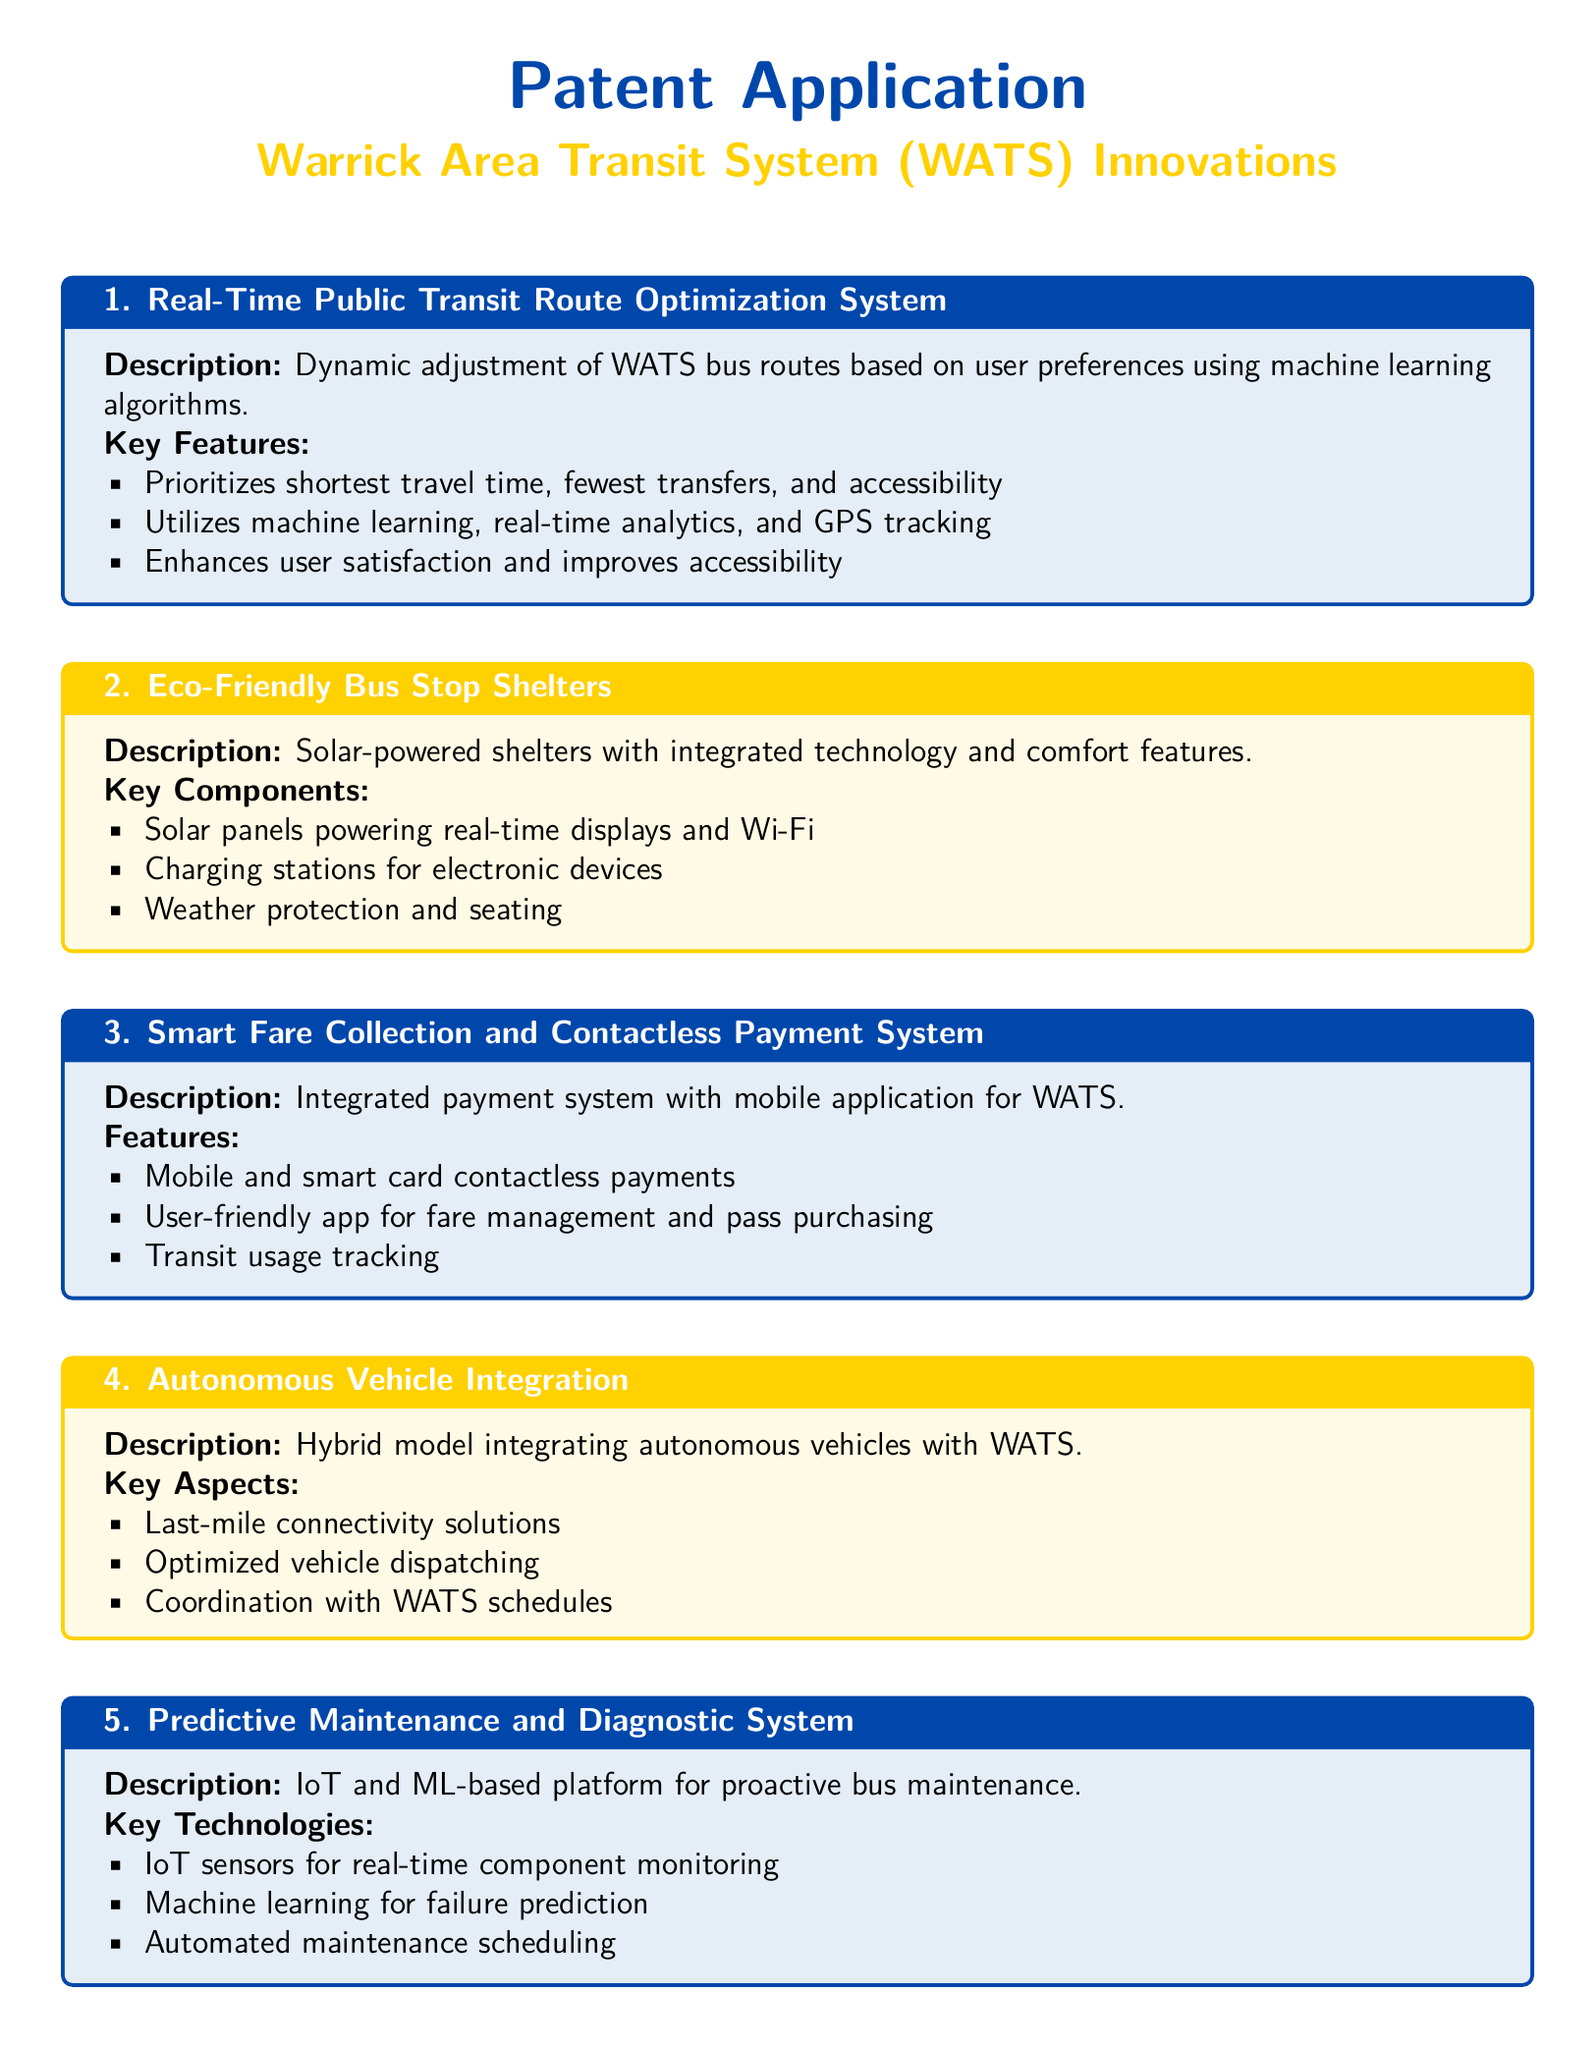What is the title of the first innovation? The title of the first innovation is "Real-Time Public Transit Route Optimization System."
Answer: Real-Time Public Transit Route Optimization System What technology does the Eco-Friendly Bus Stop Shelters use for power? The Eco-Friendly Bus Stop Shelters use solar panels for power.
Answer: Solar panels What is a feature of the Smart Fare Collection System? A feature of the Smart Fare Collection System is mobile payments.
Answer: Mobile payments What type of vehicles does the Autonomous Vehicle Integration model include? The Autonomous Vehicle Integration model includes autonomous vehicles.
Answer: Autonomous vehicles What is the focus of the Predictive Maintenance and Diagnostic System? The focus of the Predictive Maintenance and Diagnostic System is proactive maintenance.
Answer: Proactive maintenance How many innovations are described in the patent application? The patent application describes five innovations.
Answer: Five 